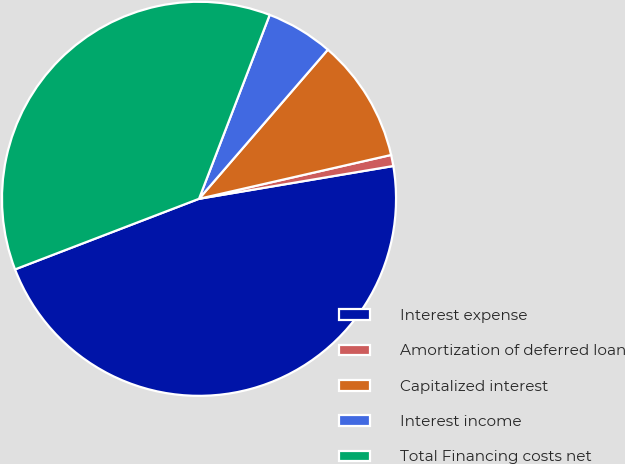Convert chart. <chart><loc_0><loc_0><loc_500><loc_500><pie_chart><fcel>Interest expense<fcel>Amortization of deferred loan<fcel>Capitalized interest<fcel>Interest income<fcel>Total Financing costs net<nl><fcel>46.83%<fcel>0.91%<fcel>10.09%<fcel>5.5%<fcel>36.67%<nl></chart> 